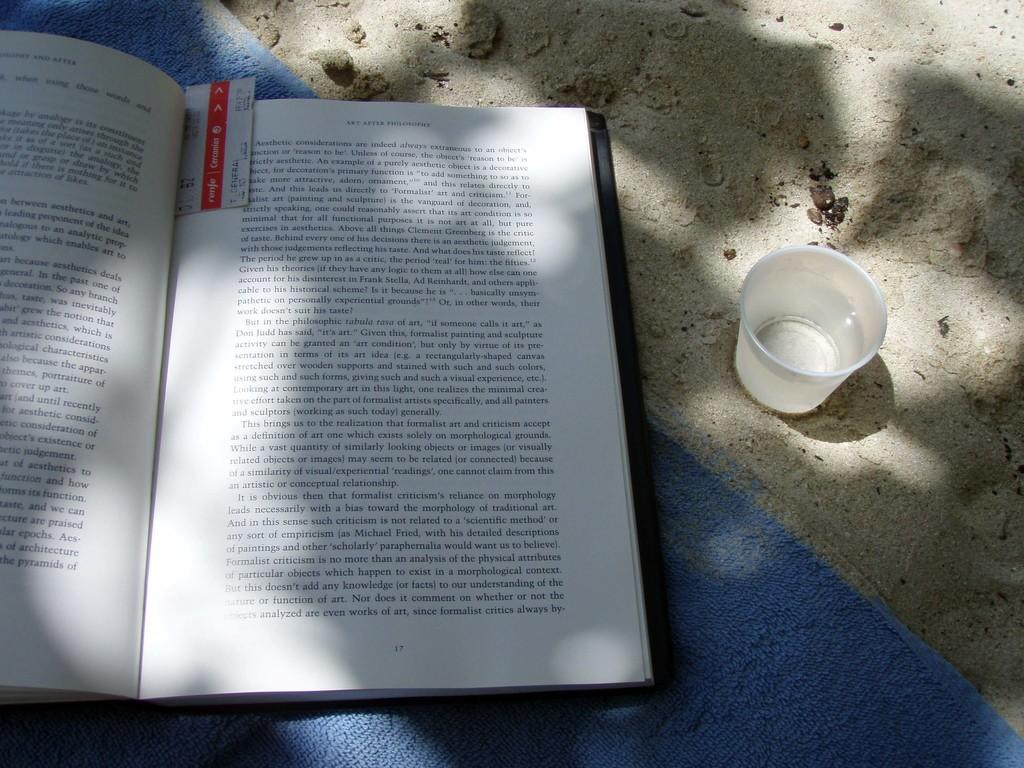<image>
Offer a succinct explanation of the picture presented. A book is open to a page that has the word always near the end. 